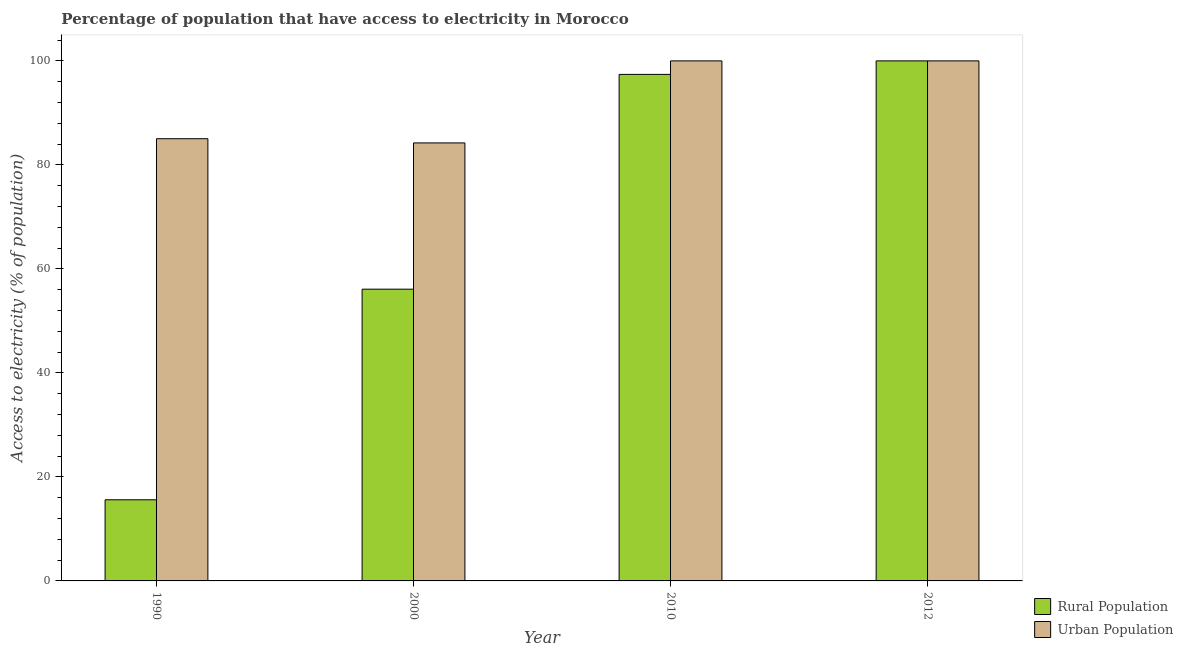How many different coloured bars are there?
Give a very brief answer. 2. How many groups of bars are there?
Provide a succinct answer. 4. Are the number of bars on each tick of the X-axis equal?
Provide a succinct answer. Yes. How many bars are there on the 4th tick from the left?
Make the answer very short. 2. What is the label of the 2nd group of bars from the left?
Offer a very short reply. 2000. Across all years, what is the maximum percentage of rural population having access to electricity?
Provide a succinct answer. 100. Across all years, what is the minimum percentage of urban population having access to electricity?
Your answer should be very brief. 84.22. In which year was the percentage of urban population having access to electricity minimum?
Offer a terse response. 2000. What is the total percentage of rural population having access to electricity in the graph?
Provide a short and direct response. 269.1. What is the difference between the percentage of urban population having access to electricity in 2000 and that in 2010?
Ensure brevity in your answer.  -15.78. What is the average percentage of urban population having access to electricity per year?
Your answer should be compact. 92.31. In the year 2012, what is the difference between the percentage of rural population having access to electricity and percentage of urban population having access to electricity?
Ensure brevity in your answer.  0. In how many years, is the percentage of rural population having access to electricity greater than 88 %?
Your response must be concise. 2. What is the ratio of the percentage of rural population having access to electricity in 1990 to that in 2010?
Offer a very short reply. 0.16. What is the difference between the highest and the second highest percentage of urban population having access to electricity?
Your response must be concise. 0. What is the difference between the highest and the lowest percentage of urban population having access to electricity?
Give a very brief answer. 15.78. What does the 2nd bar from the left in 1990 represents?
Provide a short and direct response. Urban Population. What does the 2nd bar from the right in 2000 represents?
Your answer should be compact. Rural Population. Are all the bars in the graph horizontal?
Offer a terse response. No. Are the values on the major ticks of Y-axis written in scientific E-notation?
Your answer should be very brief. No. Does the graph contain any zero values?
Your answer should be very brief. No. Where does the legend appear in the graph?
Provide a short and direct response. Bottom right. How are the legend labels stacked?
Make the answer very short. Vertical. What is the title of the graph?
Provide a succinct answer. Percentage of population that have access to electricity in Morocco. What is the label or title of the X-axis?
Keep it short and to the point. Year. What is the label or title of the Y-axis?
Offer a very short reply. Access to electricity (% of population). What is the Access to electricity (% of population) of Rural Population in 1990?
Your answer should be very brief. 15.6. What is the Access to electricity (% of population) of Urban Population in 1990?
Provide a succinct answer. 85.03. What is the Access to electricity (% of population) in Rural Population in 2000?
Offer a terse response. 56.1. What is the Access to electricity (% of population) in Urban Population in 2000?
Offer a terse response. 84.22. What is the Access to electricity (% of population) of Rural Population in 2010?
Your answer should be compact. 97.4. What is the Access to electricity (% of population) of Urban Population in 2010?
Your answer should be compact. 100. What is the Access to electricity (% of population) in Rural Population in 2012?
Ensure brevity in your answer.  100. What is the Access to electricity (% of population) in Urban Population in 2012?
Keep it short and to the point. 100. Across all years, what is the minimum Access to electricity (% of population) in Urban Population?
Offer a terse response. 84.22. What is the total Access to electricity (% of population) in Rural Population in the graph?
Ensure brevity in your answer.  269.1. What is the total Access to electricity (% of population) of Urban Population in the graph?
Ensure brevity in your answer.  369.26. What is the difference between the Access to electricity (% of population) of Rural Population in 1990 and that in 2000?
Provide a succinct answer. -40.5. What is the difference between the Access to electricity (% of population) of Urban Population in 1990 and that in 2000?
Your answer should be very brief. 0.81. What is the difference between the Access to electricity (% of population) in Rural Population in 1990 and that in 2010?
Offer a terse response. -81.8. What is the difference between the Access to electricity (% of population) of Urban Population in 1990 and that in 2010?
Offer a very short reply. -14.97. What is the difference between the Access to electricity (% of population) of Rural Population in 1990 and that in 2012?
Offer a terse response. -84.4. What is the difference between the Access to electricity (% of population) in Urban Population in 1990 and that in 2012?
Provide a succinct answer. -14.97. What is the difference between the Access to electricity (% of population) in Rural Population in 2000 and that in 2010?
Ensure brevity in your answer.  -41.3. What is the difference between the Access to electricity (% of population) in Urban Population in 2000 and that in 2010?
Keep it short and to the point. -15.78. What is the difference between the Access to electricity (% of population) of Rural Population in 2000 and that in 2012?
Your answer should be very brief. -43.9. What is the difference between the Access to electricity (% of population) in Urban Population in 2000 and that in 2012?
Offer a terse response. -15.78. What is the difference between the Access to electricity (% of population) of Rural Population in 2010 and that in 2012?
Offer a terse response. -2.6. What is the difference between the Access to electricity (% of population) of Rural Population in 1990 and the Access to electricity (% of population) of Urban Population in 2000?
Give a very brief answer. -68.62. What is the difference between the Access to electricity (% of population) of Rural Population in 1990 and the Access to electricity (% of population) of Urban Population in 2010?
Offer a very short reply. -84.4. What is the difference between the Access to electricity (% of population) in Rural Population in 1990 and the Access to electricity (% of population) in Urban Population in 2012?
Provide a short and direct response. -84.4. What is the difference between the Access to electricity (% of population) in Rural Population in 2000 and the Access to electricity (% of population) in Urban Population in 2010?
Offer a very short reply. -43.9. What is the difference between the Access to electricity (% of population) in Rural Population in 2000 and the Access to electricity (% of population) in Urban Population in 2012?
Give a very brief answer. -43.9. What is the average Access to electricity (% of population) in Rural Population per year?
Your response must be concise. 67.28. What is the average Access to electricity (% of population) of Urban Population per year?
Give a very brief answer. 92.31. In the year 1990, what is the difference between the Access to electricity (% of population) in Rural Population and Access to electricity (% of population) in Urban Population?
Your answer should be very brief. -69.43. In the year 2000, what is the difference between the Access to electricity (% of population) of Rural Population and Access to electricity (% of population) of Urban Population?
Provide a succinct answer. -28.12. What is the ratio of the Access to electricity (% of population) in Rural Population in 1990 to that in 2000?
Keep it short and to the point. 0.28. What is the ratio of the Access to electricity (% of population) in Urban Population in 1990 to that in 2000?
Your answer should be very brief. 1.01. What is the ratio of the Access to electricity (% of population) of Rural Population in 1990 to that in 2010?
Your response must be concise. 0.16. What is the ratio of the Access to electricity (% of population) in Urban Population in 1990 to that in 2010?
Offer a terse response. 0.85. What is the ratio of the Access to electricity (% of population) in Rural Population in 1990 to that in 2012?
Provide a short and direct response. 0.16. What is the ratio of the Access to electricity (% of population) of Urban Population in 1990 to that in 2012?
Your answer should be compact. 0.85. What is the ratio of the Access to electricity (% of population) of Rural Population in 2000 to that in 2010?
Keep it short and to the point. 0.58. What is the ratio of the Access to electricity (% of population) in Urban Population in 2000 to that in 2010?
Ensure brevity in your answer.  0.84. What is the ratio of the Access to electricity (% of population) in Rural Population in 2000 to that in 2012?
Make the answer very short. 0.56. What is the ratio of the Access to electricity (% of population) of Urban Population in 2000 to that in 2012?
Make the answer very short. 0.84. What is the ratio of the Access to electricity (% of population) in Urban Population in 2010 to that in 2012?
Offer a very short reply. 1. What is the difference between the highest and the second highest Access to electricity (% of population) in Urban Population?
Your answer should be compact. 0. What is the difference between the highest and the lowest Access to electricity (% of population) in Rural Population?
Give a very brief answer. 84.4. What is the difference between the highest and the lowest Access to electricity (% of population) of Urban Population?
Ensure brevity in your answer.  15.78. 